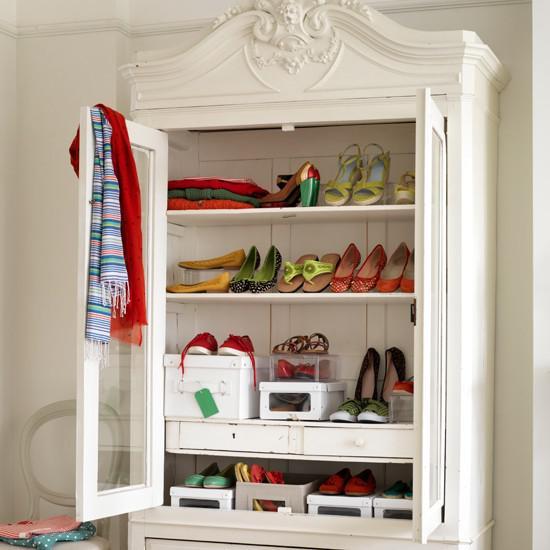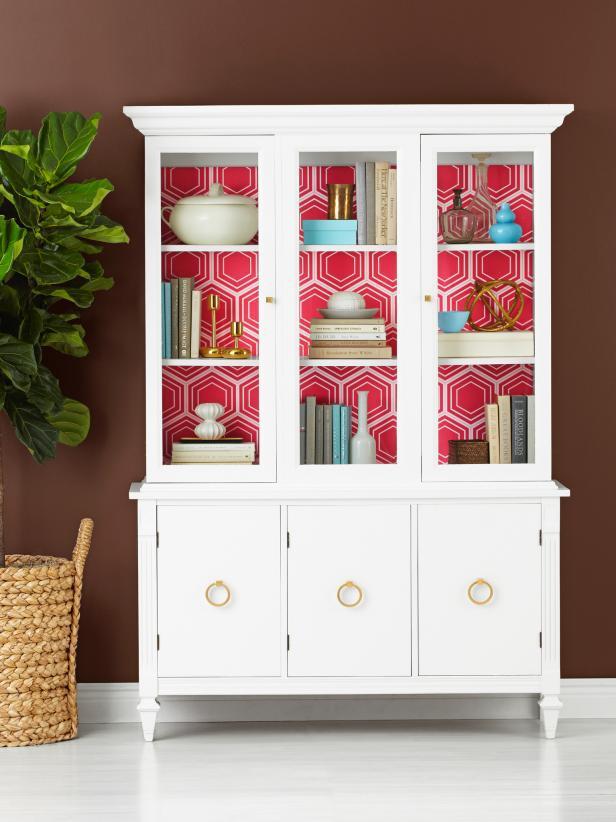The first image is the image on the left, the second image is the image on the right. Examine the images to the left and right. Is the description "The cabinet on the left is rich brown wood, and the cabinet on the right is white, with scrollwork and legs on the base." accurate? Answer yes or no. No. The first image is the image on the left, the second image is the image on the right. Assess this claim about the two images: "A wooden hutch with three glass doors in its upper section has a center section of drawers between two solid doors in the bottom section.". Correct or not? Answer yes or no. No. 